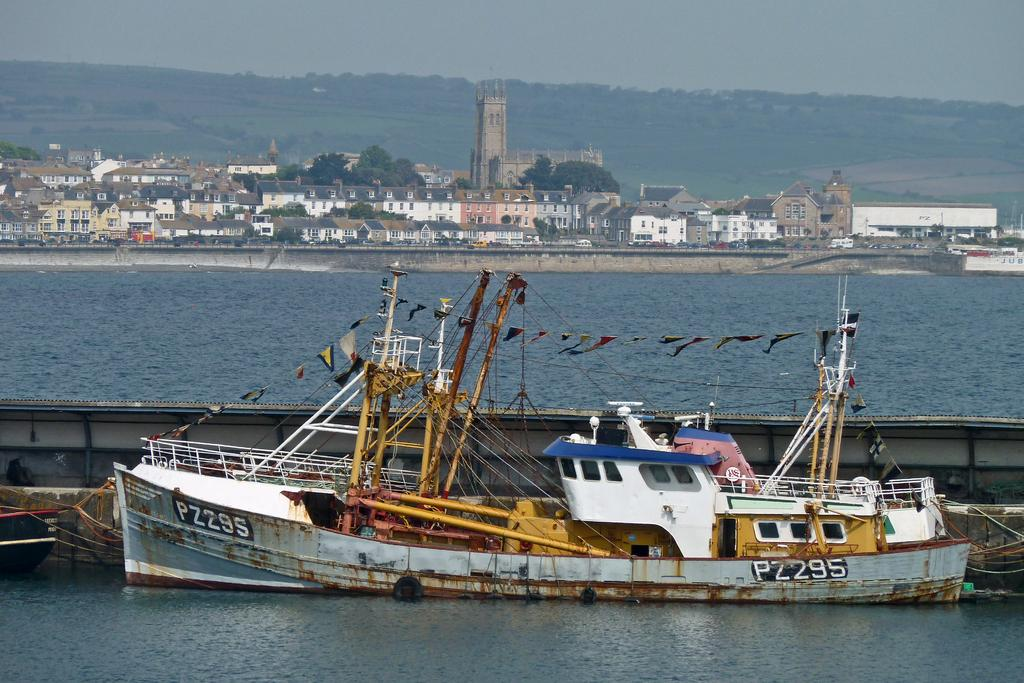What is the main subject of the image? The main subject of the image is a boat. Where is the boat located? The boat is on the water. What can be seen in the background of the image? There are buildings and trees in the background of the image. What is visible at the top of the image? The sky is visible at the top of the image. What type of boot is being worn by the person in the boat? There is no person visible in the boat, and therefore no boots can be observed. What color is the shirt of the person standing near the trees in the background? There is no person standing near the trees in the background, so it is not possible to determine the color of their shirt. 